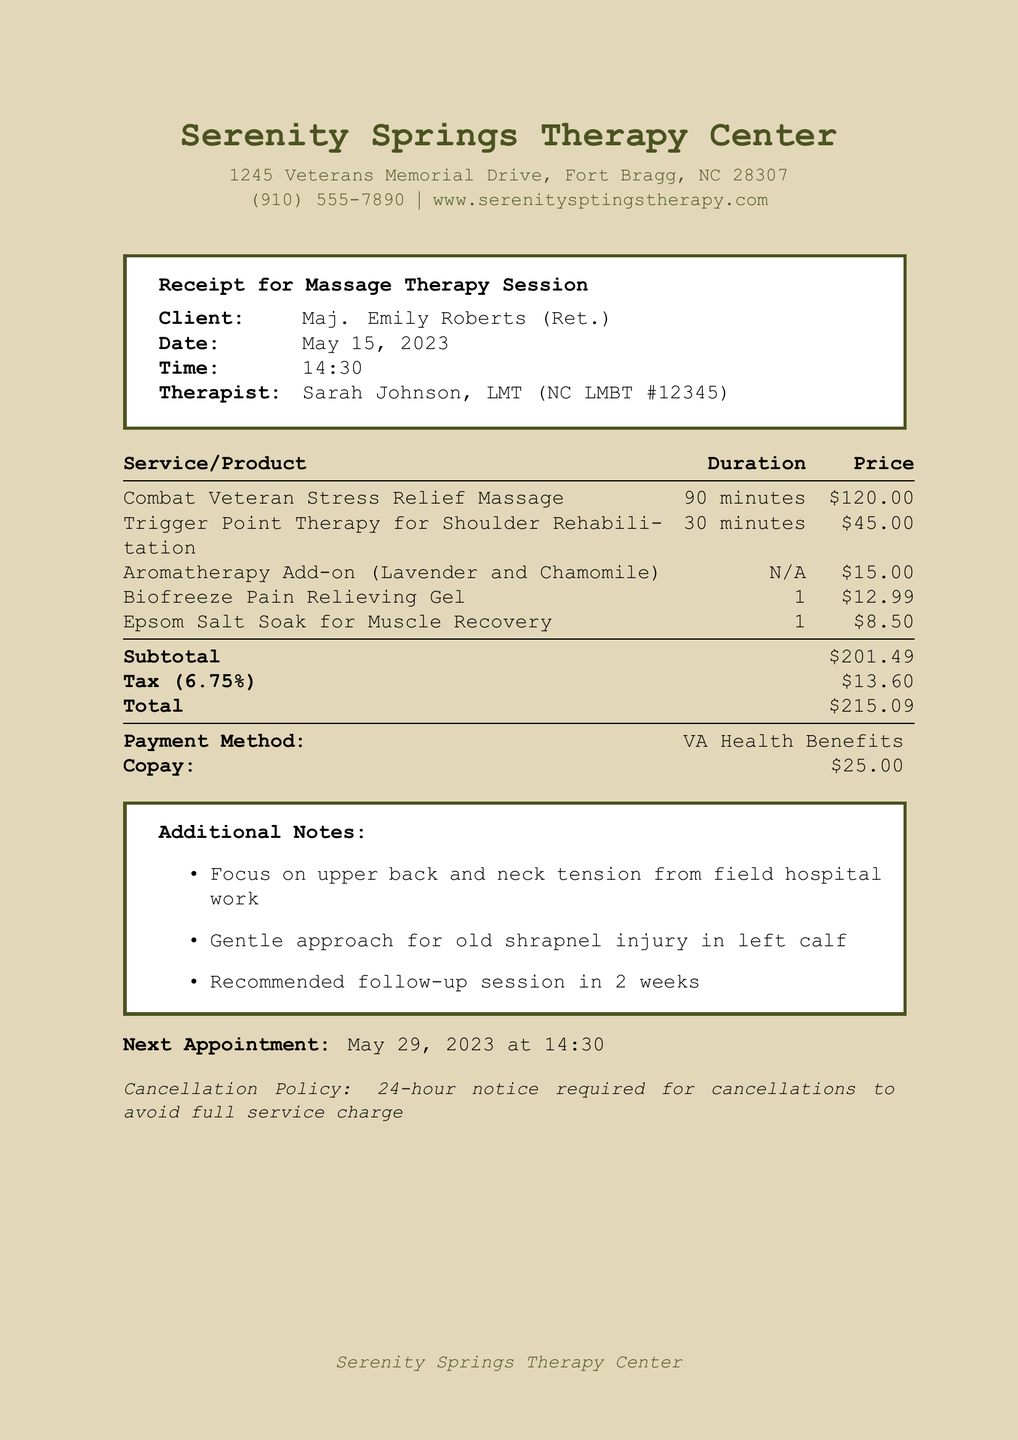What is the business name? The business name is listed at the top of the receipt.
Answer: Serenity Springs Therapy Center Who is the therapist? The therapist's name is indicated in the receipt details.
Answer: Sarah Johnson, LMT What is the date of the session? The date is specified in the client information section of the receipt.
Answer: May 15, 2023 What is the total amount charged? The total amount is the final sum shown on the receipt.
Answer: $215.09 What service includes aromatherapy? The service description explicitly mentions the aromatherapy add-on.
Answer: Aromatherapy Add-on (Lavender and Chamomile) How long is the Combat Veteran Stress Relief Massage? The duration is provided next to the service name on the receipt.
Answer: 90 minutes What is the copay amount? The copay amount is listed in the payment information section.
Answer: $25.00 What was recommended for the follow-up? The additional notes section mentions the follow-up recommendation.
Answer: Follow-up session in 2 weeks What is the cancellation policy? The cancellation policy is clearly stated at the bottom of the receipt.
Answer: 24-hour notice required for cancellations to avoid full service charge 